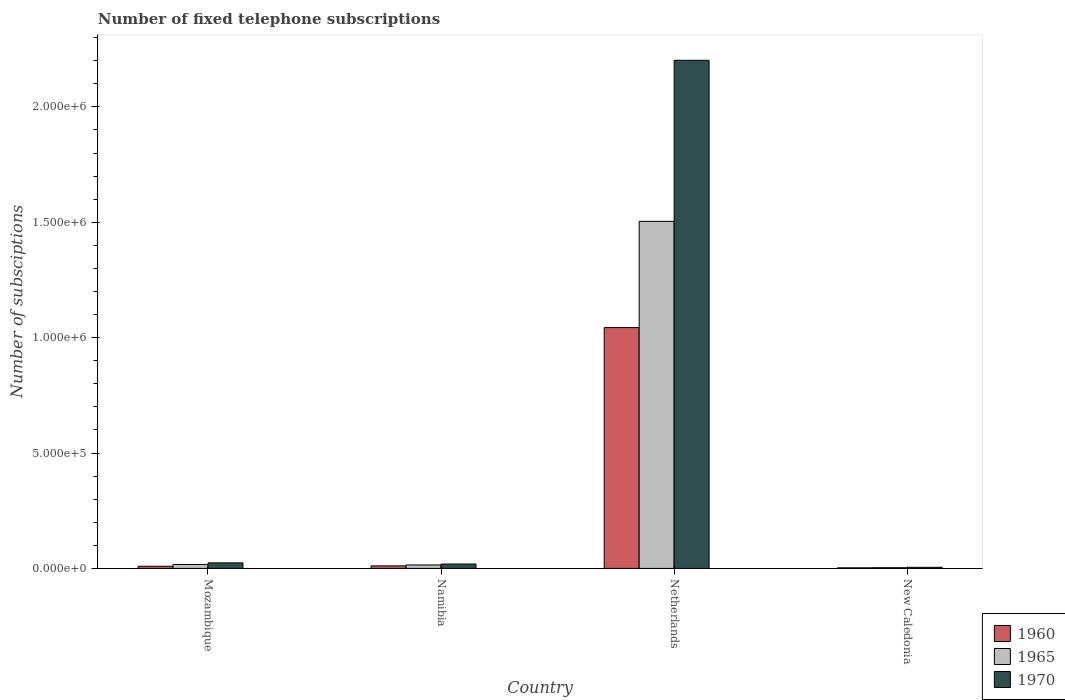How many different coloured bars are there?
Provide a short and direct response. 3. How many groups of bars are there?
Provide a succinct answer. 4. Are the number of bars on each tick of the X-axis equal?
Your answer should be compact. Yes. What is the label of the 1st group of bars from the left?
Ensure brevity in your answer.  Mozambique. In how many cases, is the number of bars for a given country not equal to the number of legend labels?
Give a very brief answer. 0. What is the number of fixed telephone subscriptions in 1970 in Mozambique?
Offer a terse response. 2.40e+04. Across all countries, what is the maximum number of fixed telephone subscriptions in 1970?
Provide a succinct answer. 2.20e+06. Across all countries, what is the minimum number of fixed telephone subscriptions in 1970?
Your answer should be compact. 4700. In which country was the number of fixed telephone subscriptions in 1970 minimum?
Offer a very short reply. New Caledonia. What is the total number of fixed telephone subscriptions in 1960 in the graph?
Offer a very short reply. 1.07e+06. What is the difference between the number of fixed telephone subscriptions in 1960 in Mozambique and that in Netherlands?
Provide a succinct answer. -1.03e+06. What is the difference between the number of fixed telephone subscriptions in 1965 in Mozambique and the number of fixed telephone subscriptions in 1960 in Netherlands?
Your response must be concise. -1.03e+06. What is the average number of fixed telephone subscriptions in 1960 per country?
Your response must be concise. 2.67e+05. What is the difference between the number of fixed telephone subscriptions of/in 1960 and number of fixed telephone subscriptions of/in 1965 in Netherlands?
Offer a very short reply. -4.60e+05. In how many countries, is the number of fixed telephone subscriptions in 1960 greater than 100000?
Make the answer very short. 1. What is the ratio of the number of fixed telephone subscriptions in 1965 in Mozambique to that in Namibia?
Ensure brevity in your answer.  1.13. Is the number of fixed telephone subscriptions in 1960 in Namibia less than that in Netherlands?
Your answer should be compact. Yes. Is the difference between the number of fixed telephone subscriptions in 1960 in Namibia and Netherlands greater than the difference between the number of fixed telephone subscriptions in 1965 in Namibia and Netherlands?
Your answer should be very brief. Yes. What is the difference between the highest and the second highest number of fixed telephone subscriptions in 1970?
Offer a terse response. 2.18e+06. What is the difference between the highest and the lowest number of fixed telephone subscriptions in 1965?
Your answer should be compact. 1.50e+06. What does the 1st bar from the right in Netherlands represents?
Your answer should be very brief. 1970. Is it the case that in every country, the sum of the number of fixed telephone subscriptions in 1965 and number of fixed telephone subscriptions in 1970 is greater than the number of fixed telephone subscriptions in 1960?
Give a very brief answer. Yes. How many bars are there?
Your response must be concise. 12. Are all the bars in the graph horizontal?
Provide a succinct answer. No. Are the values on the major ticks of Y-axis written in scientific E-notation?
Offer a terse response. Yes. Does the graph contain any zero values?
Provide a short and direct response. No. How many legend labels are there?
Your answer should be very brief. 3. How are the legend labels stacked?
Give a very brief answer. Vertical. What is the title of the graph?
Your response must be concise. Number of fixed telephone subscriptions. Does "1975" appear as one of the legend labels in the graph?
Keep it short and to the point. No. What is the label or title of the X-axis?
Offer a terse response. Country. What is the label or title of the Y-axis?
Give a very brief answer. Number of subsciptions. What is the Number of subsciptions of 1960 in Mozambique?
Ensure brevity in your answer.  9403. What is the Number of subsciptions in 1965 in Mozambique?
Make the answer very short. 1.70e+04. What is the Number of subsciptions in 1970 in Mozambique?
Ensure brevity in your answer.  2.40e+04. What is the Number of subsciptions in 1960 in Namibia?
Give a very brief answer. 1.10e+04. What is the Number of subsciptions of 1965 in Namibia?
Give a very brief answer. 1.50e+04. What is the Number of subsciptions of 1970 in Namibia?
Your answer should be compact. 1.90e+04. What is the Number of subsciptions of 1960 in Netherlands?
Provide a succinct answer. 1.04e+06. What is the Number of subsciptions of 1965 in Netherlands?
Keep it short and to the point. 1.50e+06. What is the Number of subsciptions of 1970 in Netherlands?
Offer a terse response. 2.20e+06. What is the Number of subsciptions in 1960 in New Caledonia?
Your response must be concise. 2394. What is the Number of subsciptions in 1965 in New Caledonia?
Your answer should be very brief. 3100. What is the Number of subsciptions in 1970 in New Caledonia?
Keep it short and to the point. 4700. Across all countries, what is the maximum Number of subsciptions of 1960?
Ensure brevity in your answer.  1.04e+06. Across all countries, what is the maximum Number of subsciptions of 1965?
Your answer should be compact. 1.50e+06. Across all countries, what is the maximum Number of subsciptions of 1970?
Your answer should be compact. 2.20e+06. Across all countries, what is the minimum Number of subsciptions in 1960?
Keep it short and to the point. 2394. Across all countries, what is the minimum Number of subsciptions of 1965?
Make the answer very short. 3100. Across all countries, what is the minimum Number of subsciptions of 1970?
Your response must be concise. 4700. What is the total Number of subsciptions of 1960 in the graph?
Provide a short and direct response. 1.07e+06. What is the total Number of subsciptions of 1965 in the graph?
Your response must be concise. 1.54e+06. What is the total Number of subsciptions of 1970 in the graph?
Your answer should be very brief. 2.25e+06. What is the difference between the Number of subsciptions of 1960 in Mozambique and that in Namibia?
Make the answer very short. -1597. What is the difference between the Number of subsciptions of 1965 in Mozambique and that in Namibia?
Keep it short and to the point. 2000. What is the difference between the Number of subsciptions of 1960 in Mozambique and that in Netherlands?
Your response must be concise. -1.03e+06. What is the difference between the Number of subsciptions of 1965 in Mozambique and that in Netherlands?
Make the answer very short. -1.49e+06. What is the difference between the Number of subsciptions in 1970 in Mozambique and that in Netherlands?
Keep it short and to the point. -2.18e+06. What is the difference between the Number of subsciptions of 1960 in Mozambique and that in New Caledonia?
Offer a very short reply. 7009. What is the difference between the Number of subsciptions in 1965 in Mozambique and that in New Caledonia?
Provide a short and direct response. 1.39e+04. What is the difference between the Number of subsciptions in 1970 in Mozambique and that in New Caledonia?
Provide a succinct answer. 1.93e+04. What is the difference between the Number of subsciptions in 1960 in Namibia and that in Netherlands?
Ensure brevity in your answer.  -1.03e+06. What is the difference between the Number of subsciptions in 1965 in Namibia and that in Netherlands?
Your answer should be very brief. -1.49e+06. What is the difference between the Number of subsciptions of 1970 in Namibia and that in Netherlands?
Provide a succinct answer. -2.18e+06. What is the difference between the Number of subsciptions in 1960 in Namibia and that in New Caledonia?
Provide a short and direct response. 8606. What is the difference between the Number of subsciptions of 1965 in Namibia and that in New Caledonia?
Offer a terse response. 1.19e+04. What is the difference between the Number of subsciptions of 1970 in Namibia and that in New Caledonia?
Provide a short and direct response. 1.43e+04. What is the difference between the Number of subsciptions of 1960 in Netherlands and that in New Caledonia?
Provide a succinct answer. 1.04e+06. What is the difference between the Number of subsciptions in 1965 in Netherlands and that in New Caledonia?
Keep it short and to the point. 1.50e+06. What is the difference between the Number of subsciptions of 1970 in Netherlands and that in New Caledonia?
Your response must be concise. 2.20e+06. What is the difference between the Number of subsciptions of 1960 in Mozambique and the Number of subsciptions of 1965 in Namibia?
Give a very brief answer. -5597. What is the difference between the Number of subsciptions in 1960 in Mozambique and the Number of subsciptions in 1970 in Namibia?
Keep it short and to the point. -9597. What is the difference between the Number of subsciptions in 1965 in Mozambique and the Number of subsciptions in 1970 in Namibia?
Make the answer very short. -2000. What is the difference between the Number of subsciptions of 1960 in Mozambique and the Number of subsciptions of 1965 in Netherlands?
Make the answer very short. -1.49e+06. What is the difference between the Number of subsciptions in 1960 in Mozambique and the Number of subsciptions in 1970 in Netherlands?
Provide a short and direct response. -2.19e+06. What is the difference between the Number of subsciptions of 1965 in Mozambique and the Number of subsciptions of 1970 in Netherlands?
Offer a very short reply. -2.18e+06. What is the difference between the Number of subsciptions in 1960 in Mozambique and the Number of subsciptions in 1965 in New Caledonia?
Provide a short and direct response. 6303. What is the difference between the Number of subsciptions in 1960 in Mozambique and the Number of subsciptions in 1970 in New Caledonia?
Your response must be concise. 4703. What is the difference between the Number of subsciptions of 1965 in Mozambique and the Number of subsciptions of 1970 in New Caledonia?
Offer a very short reply. 1.23e+04. What is the difference between the Number of subsciptions in 1960 in Namibia and the Number of subsciptions in 1965 in Netherlands?
Give a very brief answer. -1.49e+06. What is the difference between the Number of subsciptions of 1960 in Namibia and the Number of subsciptions of 1970 in Netherlands?
Give a very brief answer. -2.19e+06. What is the difference between the Number of subsciptions in 1965 in Namibia and the Number of subsciptions in 1970 in Netherlands?
Your response must be concise. -2.19e+06. What is the difference between the Number of subsciptions of 1960 in Namibia and the Number of subsciptions of 1965 in New Caledonia?
Give a very brief answer. 7900. What is the difference between the Number of subsciptions of 1960 in Namibia and the Number of subsciptions of 1970 in New Caledonia?
Your answer should be compact. 6300. What is the difference between the Number of subsciptions in 1965 in Namibia and the Number of subsciptions in 1970 in New Caledonia?
Offer a terse response. 1.03e+04. What is the difference between the Number of subsciptions of 1960 in Netherlands and the Number of subsciptions of 1965 in New Caledonia?
Your answer should be very brief. 1.04e+06. What is the difference between the Number of subsciptions in 1960 in Netherlands and the Number of subsciptions in 1970 in New Caledonia?
Make the answer very short. 1.04e+06. What is the difference between the Number of subsciptions of 1965 in Netherlands and the Number of subsciptions of 1970 in New Caledonia?
Make the answer very short. 1.50e+06. What is the average Number of subsciptions in 1960 per country?
Provide a short and direct response. 2.67e+05. What is the average Number of subsciptions of 1965 per country?
Ensure brevity in your answer.  3.85e+05. What is the average Number of subsciptions of 1970 per country?
Offer a very short reply. 5.62e+05. What is the difference between the Number of subsciptions in 1960 and Number of subsciptions in 1965 in Mozambique?
Provide a short and direct response. -7597. What is the difference between the Number of subsciptions of 1960 and Number of subsciptions of 1970 in Mozambique?
Your answer should be compact. -1.46e+04. What is the difference between the Number of subsciptions of 1965 and Number of subsciptions of 1970 in Mozambique?
Your response must be concise. -7000. What is the difference between the Number of subsciptions of 1960 and Number of subsciptions of 1965 in Namibia?
Offer a very short reply. -4000. What is the difference between the Number of subsciptions of 1960 and Number of subsciptions of 1970 in Namibia?
Ensure brevity in your answer.  -8000. What is the difference between the Number of subsciptions in 1965 and Number of subsciptions in 1970 in Namibia?
Give a very brief answer. -4000. What is the difference between the Number of subsciptions of 1960 and Number of subsciptions of 1965 in Netherlands?
Your answer should be compact. -4.60e+05. What is the difference between the Number of subsciptions of 1960 and Number of subsciptions of 1970 in Netherlands?
Make the answer very short. -1.16e+06. What is the difference between the Number of subsciptions in 1965 and Number of subsciptions in 1970 in Netherlands?
Offer a terse response. -6.98e+05. What is the difference between the Number of subsciptions of 1960 and Number of subsciptions of 1965 in New Caledonia?
Your answer should be very brief. -706. What is the difference between the Number of subsciptions of 1960 and Number of subsciptions of 1970 in New Caledonia?
Keep it short and to the point. -2306. What is the difference between the Number of subsciptions of 1965 and Number of subsciptions of 1970 in New Caledonia?
Your answer should be compact. -1600. What is the ratio of the Number of subsciptions of 1960 in Mozambique to that in Namibia?
Give a very brief answer. 0.85. What is the ratio of the Number of subsciptions in 1965 in Mozambique to that in Namibia?
Give a very brief answer. 1.13. What is the ratio of the Number of subsciptions in 1970 in Mozambique to that in Namibia?
Provide a short and direct response. 1.26. What is the ratio of the Number of subsciptions of 1960 in Mozambique to that in Netherlands?
Your answer should be compact. 0.01. What is the ratio of the Number of subsciptions of 1965 in Mozambique to that in Netherlands?
Provide a short and direct response. 0.01. What is the ratio of the Number of subsciptions of 1970 in Mozambique to that in Netherlands?
Your answer should be very brief. 0.01. What is the ratio of the Number of subsciptions in 1960 in Mozambique to that in New Caledonia?
Your answer should be compact. 3.93. What is the ratio of the Number of subsciptions in 1965 in Mozambique to that in New Caledonia?
Your answer should be very brief. 5.48. What is the ratio of the Number of subsciptions in 1970 in Mozambique to that in New Caledonia?
Your response must be concise. 5.11. What is the ratio of the Number of subsciptions of 1960 in Namibia to that in Netherlands?
Your response must be concise. 0.01. What is the ratio of the Number of subsciptions in 1965 in Namibia to that in Netherlands?
Offer a very short reply. 0.01. What is the ratio of the Number of subsciptions of 1970 in Namibia to that in Netherlands?
Your answer should be very brief. 0.01. What is the ratio of the Number of subsciptions in 1960 in Namibia to that in New Caledonia?
Make the answer very short. 4.59. What is the ratio of the Number of subsciptions of 1965 in Namibia to that in New Caledonia?
Your answer should be very brief. 4.84. What is the ratio of the Number of subsciptions in 1970 in Namibia to that in New Caledonia?
Your answer should be compact. 4.04. What is the ratio of the Number of subsciptions of 1960 in Netherlands to that in New Caledonia?
Keep it short and to the point. 435.95. What is the ratio of the Number of subsciptions in 1965 in Netherlands to that in New Caledonia?
Offer a terse response. 485.16. What is the ratio of the Number of subsciptions in 1970 in Netherlands to that in New Caledonia?
Ensure brevity in your answer.  468.51. What is the difference between the highest and the second highest Number of subsciptions in 1960?
Your response must be concise. 1.03e+06. What is the difference between the highest and the second highest Number of subsciptions in 1965?
Provide a succinct answer. 1.49e+06. What is the difference between the highest and the second highest Number of subsciptions of 1970?
Keep it short and to the point. 2.18e+06. What is the difference between the highest and the lowest Number of subsciptions in 1960?
Offer a terse response. 1.04e+06. What is the difference between the highest and the lowest Number of subsciptions of 1965?
Give a very brief answer. 1.50e+06. What is the difference between the highest and the lowest Number of subsciptions in 1970?
Make the answer very short. 2.20e+06. 